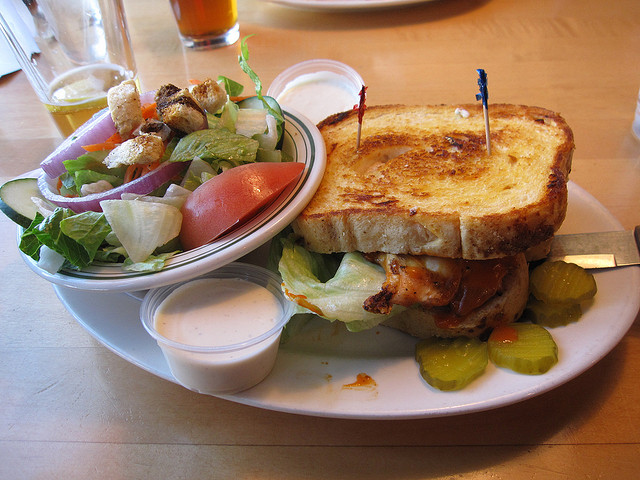Can you tell me more about the meal shown in the image? Certainly! The image showcases a hearty grilled chicken sandwich served on thick, grilled bread, accompanied by a fresh side salad with croutons and a creamy dressing, and some pickles. It looks like a satisfying meal, particularly suited for a robust lunch or dinner. 